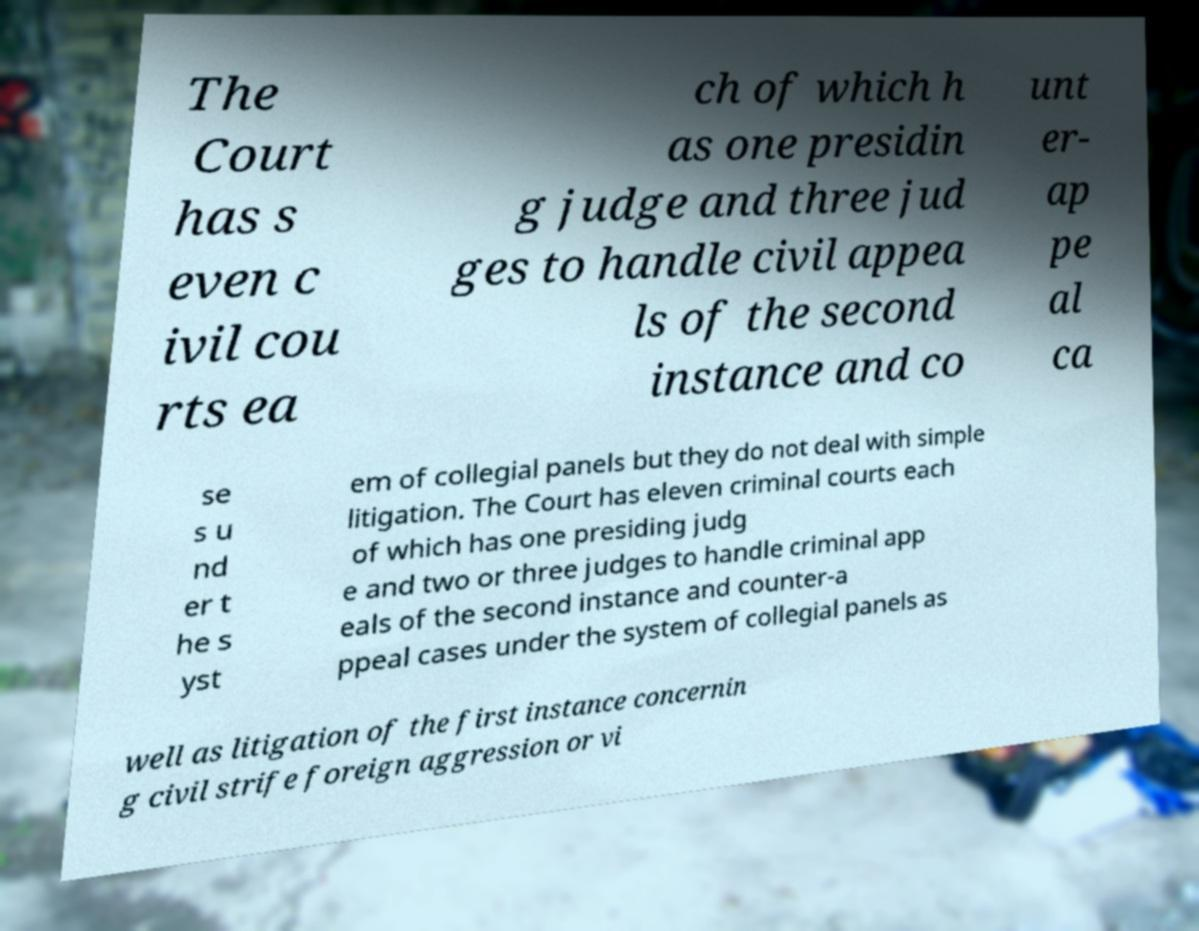There's text embedded in this image that I need extracted. Can you transcribe it verbatim? The Court has s even c ivil cou rts ea ch of which h as one presidin g judge and three jud ges to handle civil appea ls of the second instance and co unt er- ap pe al ca se s u nd er t he s yst em of collegial panels but they do not deal with simple litigation. The Court has eleven criminal courts each of which has one presiding judg e and two or three judges to handle criminal app eals of the second instance and counter-a ppeal cases under the system of collegial panels as well as litigation of the first instance concernin g civil strife foreign aggression or vi 